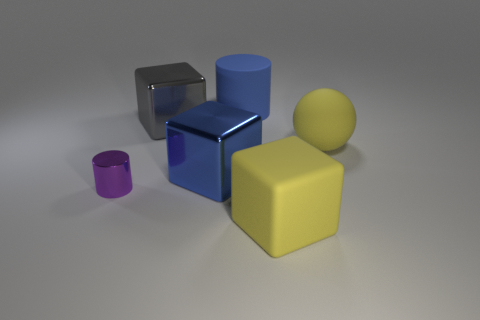There is another big metal thing that is the same shape as the big gray metallic thing; what color is it?
Your answer should be compact. Blue. What number of matte balls are behind the large thing that is in front of the small purple metallic object?
Offer a terse response. 1. What number of balls are either blue rubber objects or big metal objects?
Your answer should be very brief. 0. Are any gray cylinders visible?
Your response must be concise. No. What size is the purple shiny object that is the same shape as the big blue matte thing?
Your answer should be compact. Small. What shape is the big blue object left of the big object behind the big gray cube?
Give a very brief answer. Cube. How many blue objects are either shiny objects or large rubber things?
Your answer should be very brief. 2. The metallic cylinder is what color?
Give a very brief answer. Purple. Does the yellow matte cube have the same size as the blue metallic cube?
Make the answer very short. Yes. Is the material of the large gray block the same as the blue thing that is in front of the big gray block?
Your answer should be very brief. Yes. 